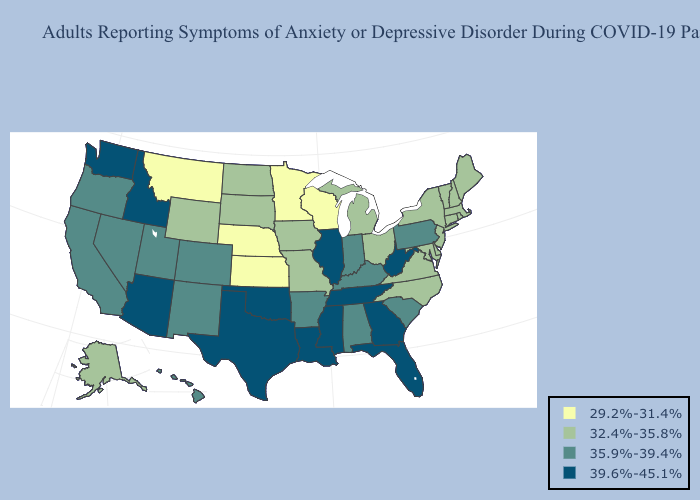What is the lowest value in the USA?
Give a very brief answer. 29.2%-31.4%. Which states have the highest value in the USA?
Quick response, please. Arizona, Florida, Georgia, Idaho, Illinois, Louisiana, Mississippi, Oklahoma, Tennessee, Texas, Washington, West Virginia. What is the highest value in the USA?
Short answer required. 39.6%-45.1%. What is the lowest value in states that border Tennessee?
Quick response, please. 32.4%-35.8%. Name the states that have a value in the range 35.9%-39.4%?
Concise answer only. Alabama, Arkansas, California, Colorado, Hawaii, Indiana, Kentucky, Nevada, New Mexico, Oregon, Pennsylvania, South Carolina, Utah. What is the value of New Hampshire?
Answer briefly. 32.4%-35.8%. Does Wisconsin have the lowest value in the USA?
Short answer required. Yes. What is the lowest value in the South?
Quick response, please. 32.4%-35.8%. Which states hav the highest value in the South?
Be succinct. Florida, Georgia, Louisiana, Mississippi, Oklahoma, Tennessee, Texas, West Virginia. Name the states that have a value in the range 39.6%-45.1%?
Quick response, please. Arizona, Florida, Georgia, Idaho, Illinois, Louisiana, Mississippi, Oklahoma, Tennessee, Texas, Washington, West Virginia. What is the value of Georgia?
Keep it brief. 39.6%-45.1%. Name the states that have a value in the range 35.9%-39.4%?
Give a very brief answer. Alabama, Arkansas, California, Colorado, Hawaii, Indiana, Kentucky, Nevada, New Mexico, Oregon, Pennsylvania, South Carolina, Utah. Among the states that border West Virginia , which have the highest value?
Quick response, please. Kentucky, Pennsylvania. What is the value of Michigan?
Short answer required. 32.4%-35.8%. Does New Mexico have the highest value in the USA?
Write a very short answer. No. 